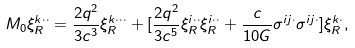Convert formula to latex. <formula><loc_0><loc_0><loc_500><loc_500>M _ { 0 } \xi _ { R } ^ { k \cdot \cdot } = \frac { 2 q ^ { 2 } } { 3 c ^ { 3 } } \xi _ { R } ^ { k \cdot \cdot \cdot } + [ \frac { 2 q ^ { 2 } } { 3 c ^ { 5 } } { \xi } _ { R } ^ { i \cdot \cdot } { \xi } _ { R } ^ { i \cdot \cdot } + \frac { c } { 1 0 G } \sigma ^ { i j \cdot } \sigma ^ { i j \cdot } ] \xi _ { R } ^ { k \cdot } ,</formula> 